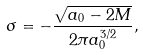Convert formula to latex. <formula><loc_0><loc_0><loc_500><loc_500>\sigma = - \frac { \sqrt { a _ { 0 } - 2 M } } { 2 \pi a _ { 0 } ^ { 3 / 2 } } ,</formula> 